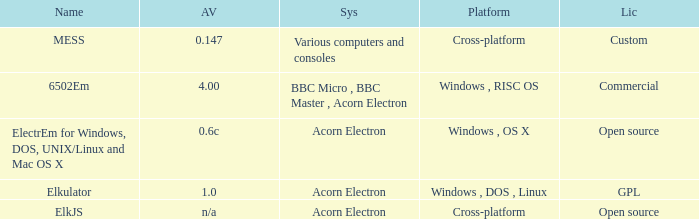Which system is named ELKJS? Acorn Electron. 